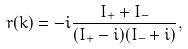Convert formula to latex. <formula><loc_0><loc_0><loc_500><loc_500>r ( k ) = - i \frac { I _ { + } + I _ { - } } { ( I _ { + } - i ) ( I _ { - } + i ) } ,</formula> 